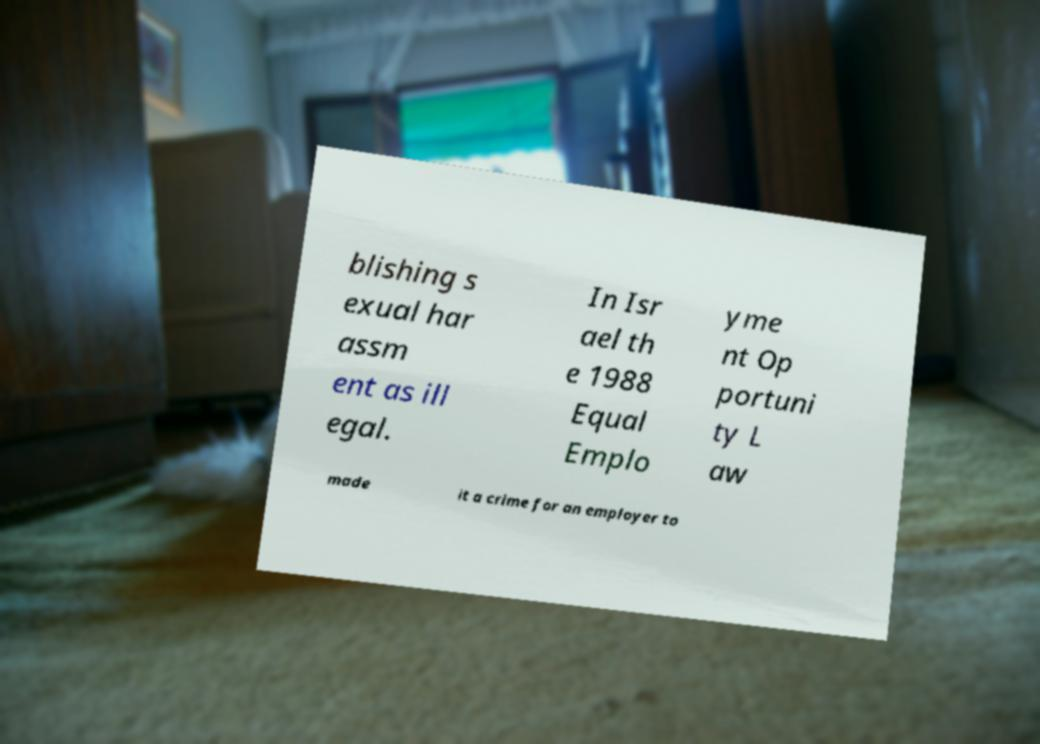Please identify and transcribe the text found in this image. blishing s exual har assm ent as ill egal. In Isr ael th e 1988 Equal Emplo yme nt Op portuni ty L aw made it a crime for an employer to 